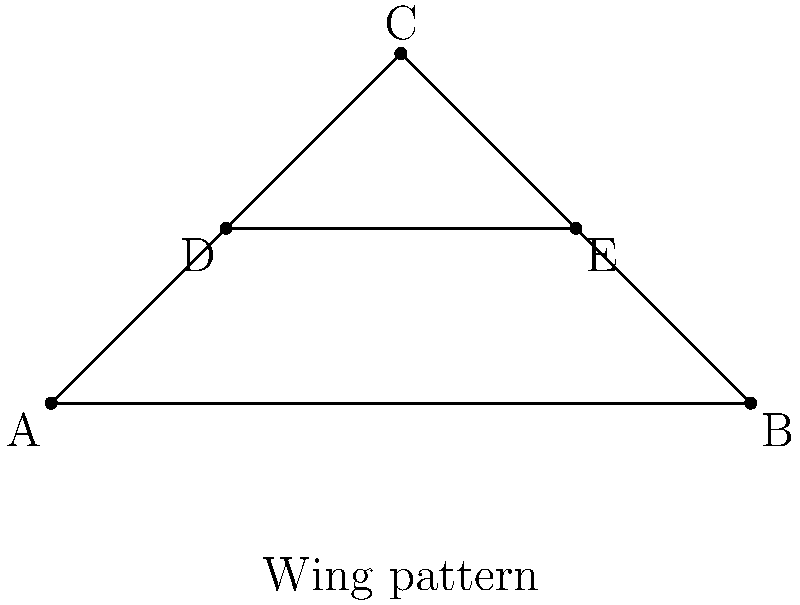In your latest butterfly photograph, you've noticed an interesting symmetry in the wing pattern. The pattern can be represented by an isosceles triangle ABC with a line DE parallel to the base AB. If AD = 0.5 cm, DE = 1 cm, and AB = 2 cm, what is the length of AC in centimeters? Let's solve this step-by-step:

1) First, we recognize that triangle ABC is isosceles, so AC = BC.

2) Line DE is parallel to AB, so triangles ADE and ABC are similar.

3) We can use the similarity ratio to solve for AC:
   $\frac{AD}{AB} = \frac{DE}{AB} = \frac{AC-AD}{AC}$

4) We know that AD = 0.5 cm, DE = 1 cm, and AB = 2 cm.

5) Substituting these values:
   $\frac{0.5}{2} = \frac{1}{2} = \frac{AC-0.5}{AC}$

6) Simplifying:
   $\frac{1}{4} = \frac{AC-0.5}{AC}$

7) Cross multiplying:
   $1 \cdot AC = 4(AC-0.5)$
   $AC = 4AC - 2$

8) Solving for AC:
   $-3AC = -2$
   $AC = \frac{2}{3}$

9) Therefore, AC = $\frac{2}{3}$ cm or approximately 0.67 cm.
Answer: $\frac{2}{3}$ cm 